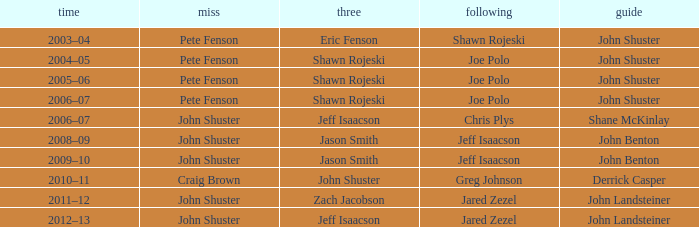In the 2005-06 season, who was the leading member with pete fenson as skip and joe polo as second? John Shuster. 